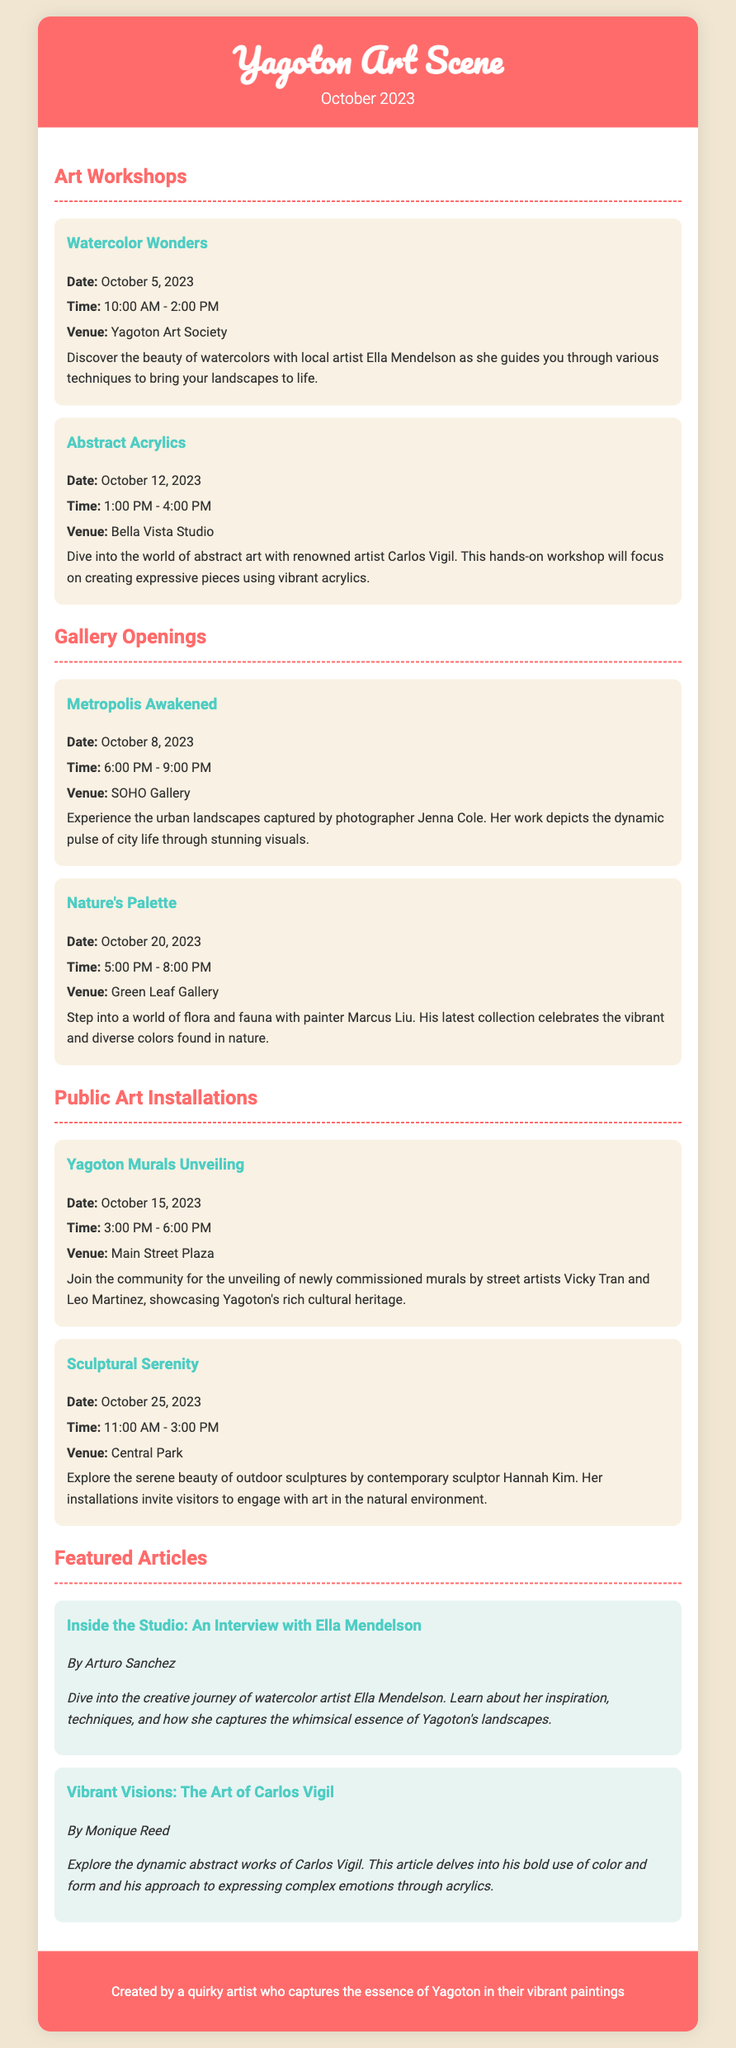What is the date of the Watercolor Wonders workshop? The date is specifically listed under the Art Workshops section, detailing when each workshop occurs.
Answer: October 5, 2023 Who is the artist featured in the interview titled "Inside the Studio"? The document identifies the subject of the feature article, providing their name and art style.
Answer: Ella Mendelson What time does the Metropolis Awakened gallery opening start? The timing for the gallery opening is provided in the event description for that specific opening.
Answer: 6:00 PM What type of art will be showcased at the Nature's Palette gallery opening? This information is found in the description of the Nature's Palette event, explaining the focus of the artwork.
Answer: Painting How many public art installations are mentioned in the document? The document lists and describes each public art installation, which can be counted.
Answer: 2 Who is the artist leading the Abstract Acrylics workshop? The document specifies the artist associated with the Abstract Acrylics workshop in the event details.
Answer: Carlos Vigil What is the theme of the sculptures featured in the Sculptural Serenity installation? The purpose of the Sculptural Serenity installation is mentioned in its description, indicating the focus of the artworks.
Answer: Serenity Which venue will host the unveiling of the Yagoton Murals? The event details provide information about the specific location where the mural unveiling will take place.
Answer: Main Street Plaza What month and year does this Playbill pertain to? The header of the document clearly states the relevant month and year for the content presented.
Answer: October 2023 